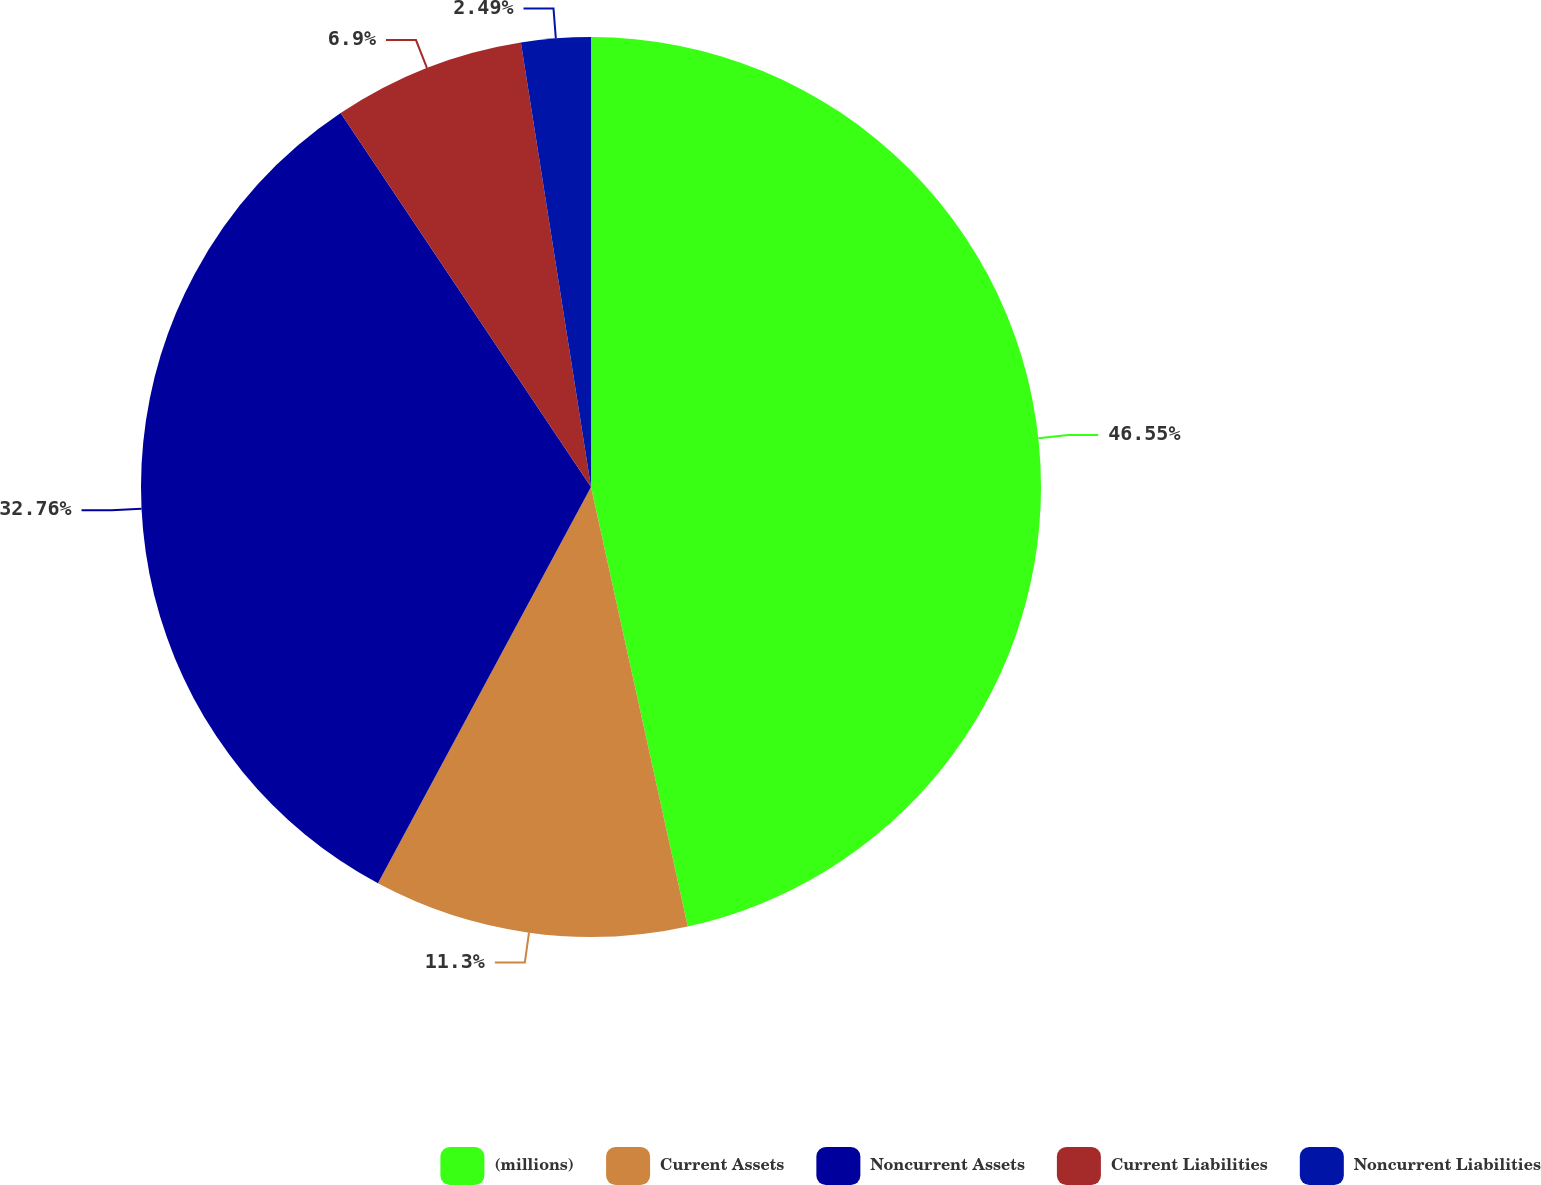Convert chart. <chart><loc_0><loc_0><loc_500><loc_500><pie_chart><fcel>(millions)<fcel>Current Assets<fcel>Noncurrent Assets<fcel>Current Liabilities<fcel>Noncurrent Liabilities<nl><fcel>46.55%<fcel>11.3%<fcel>32.76%<fcel>6.9%<fcel>2.49%<nl></chart> 